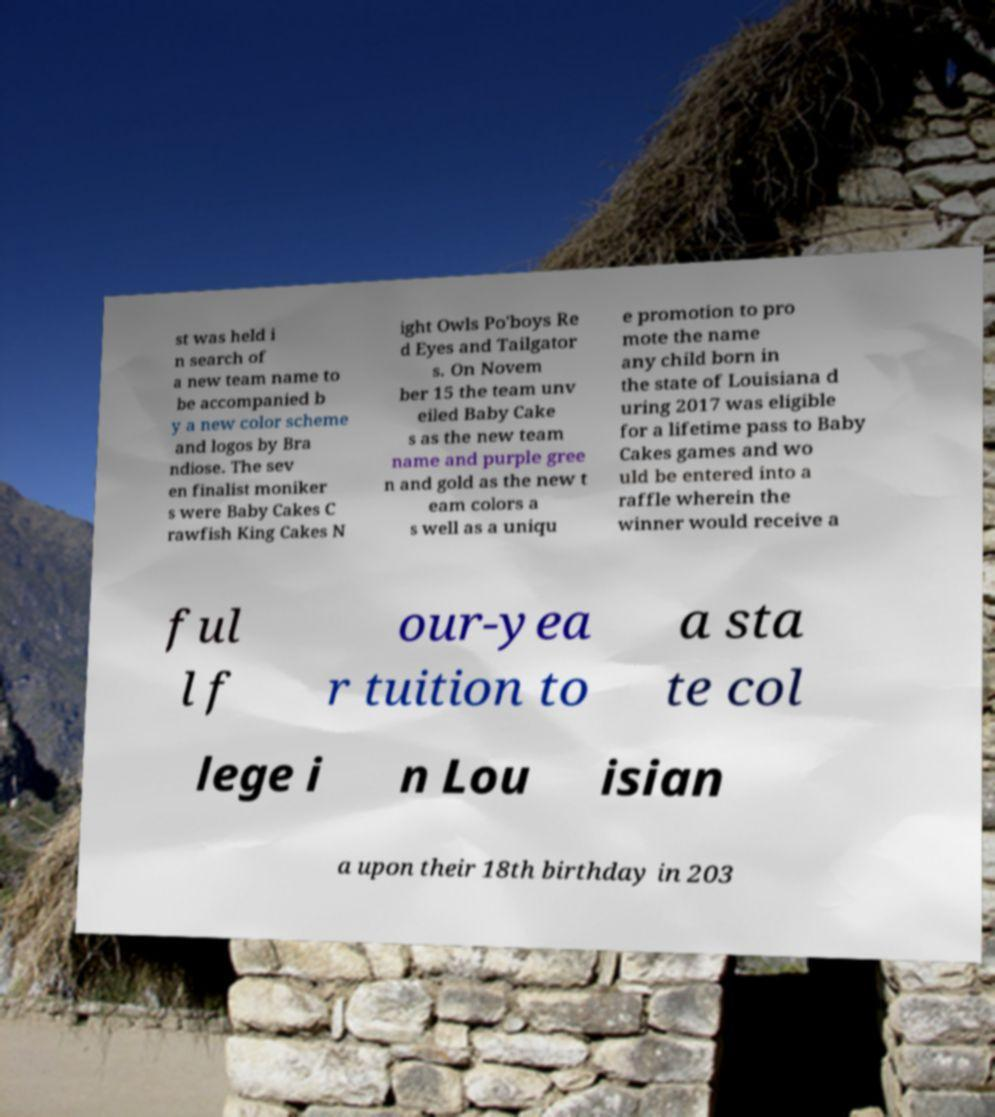Can you read and provide the text displayed in the image?This photo seems to have some interesting text. Can you extract and type it out for me? st was held i n search of a new team name to be accompanied b y a new color scheme and logos by Bra ndiose. The sev en finalist moniker s were Baby Cakes C rawfish King Cakes N ight Owls Po'boys Re d Eyes and Tailgator s. On Novem ber 15 the team unv eiled Baby Cake s as the new team name and purple gree n and gold as the new t eam colors a s well as a uniqu e promotion to pro mote the name any child born in the state of Louisiana d uring 2017 was eligible for a lifetime pass to Baby Cakes games and wo uld be entered into a raffle wherein the winner would receive a ful l f our-yea r tuition to a sta te col lege i n Lou isian a upon their 18th birthday in 203 